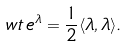Convert formula to latex. <formula><loc_0><loc_0><loc_500><loc_500>w t \, e ^ { \lambda } = \frac { 1 } { 2 } \langle \lambda , \lambda \rangle .</formula> 